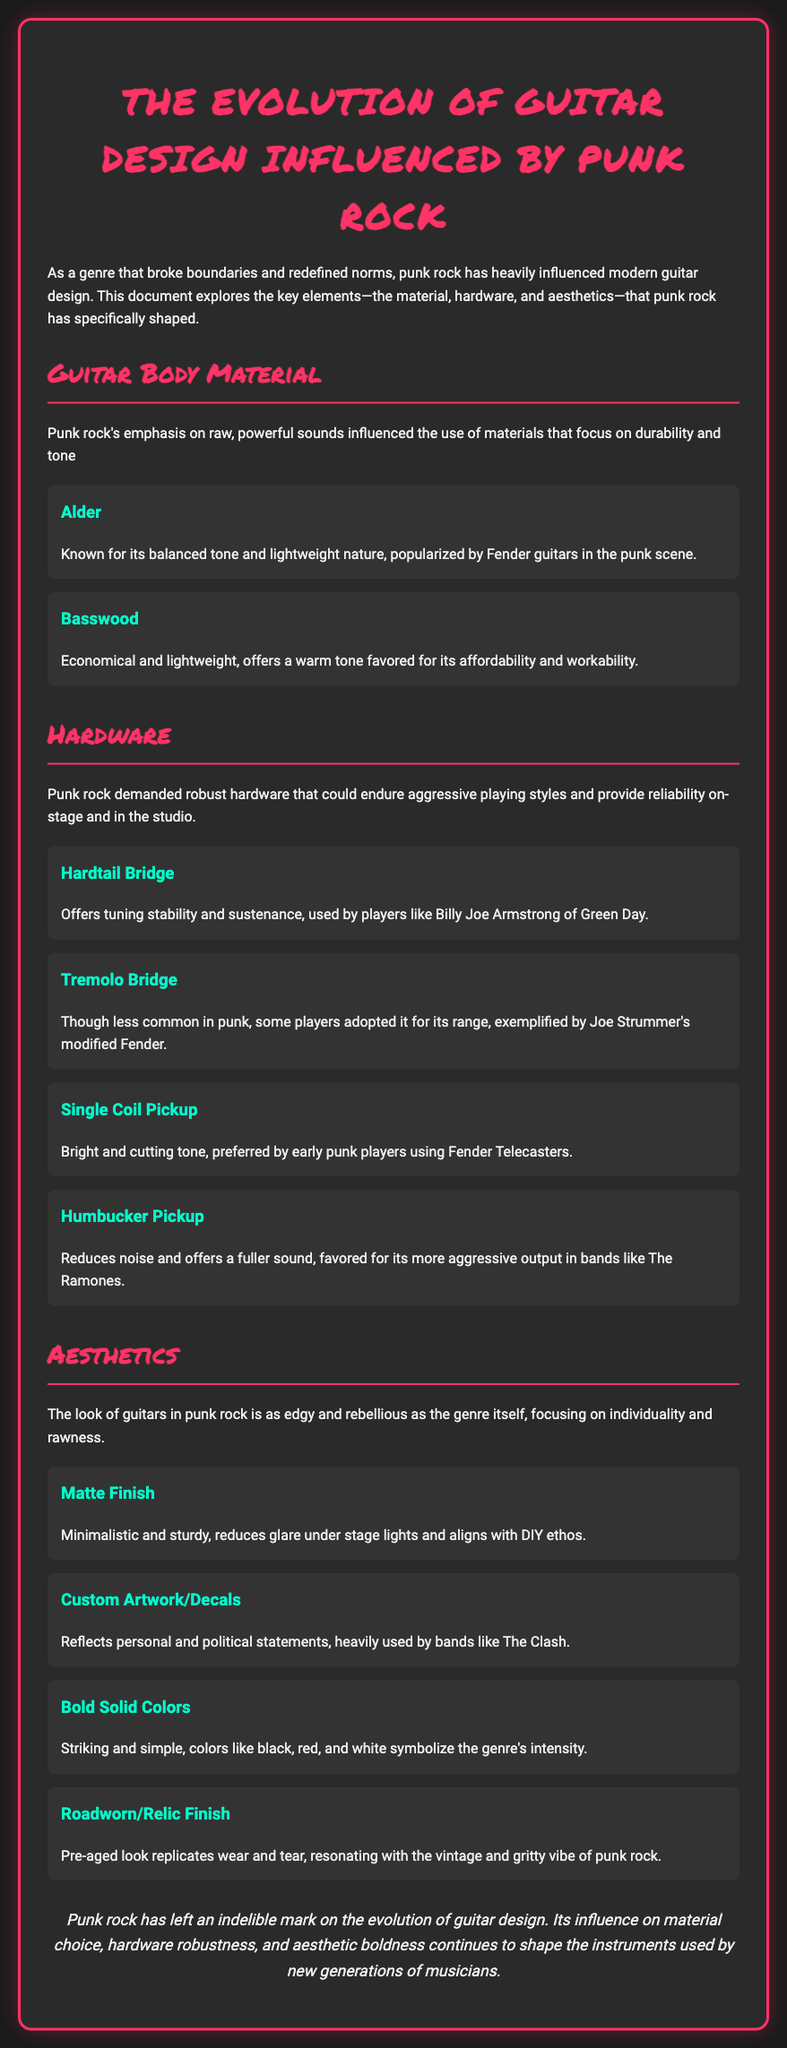what are two common guitar body materials mentioned? The document lists Alder and Basswood as common guitar body materials influenced by punk rock.
Answer: Alder, Basswood who is associated with the use of Hardtail Bridge? The document mentions Billy Joe Armstrong of Green Day in relation to the Hardtail Bridge.
Answer: Billy Joe Armstrong what type of pickup is preferred by early punk players using Fender Telecasters? The document states that Single Coil Pickup is preferred by early punk players using Fender Telecasters.
Answer: Single Coil Pickup which finish reduces glare under stage lights? The document indicates that Matte Finish reduces glare under stage lights.
Answer: Matte Finish what is a prominent color mentioned that symbolizes the intensity of punk rock? The document mentions black, red, and white as striking colors symbolizing punk rock's intensity.
Answer: Black, red, and white how does punk rock influence guitar aesthetics? The document outlines that punk rock aesthetics focus on individuality and rawness.
Answer: Individuality and rawness what is a key feature of the Humbucker Pickup mentioned? The document states that the Humbucker Pickup reduces noise and offers a fuller sound.
Answer: Reduces noise how does the document conclude about punk rock's impact? The conclusion highlights that punk rock has left an indelible mark on the evolution of guitar design.
Answer: Indelible mark on guitar design 